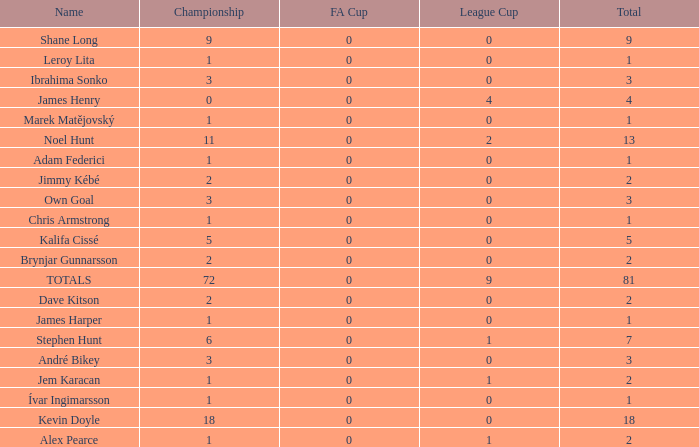What is the total championships of James Henry that has a league cup more than 1? 0.0. 